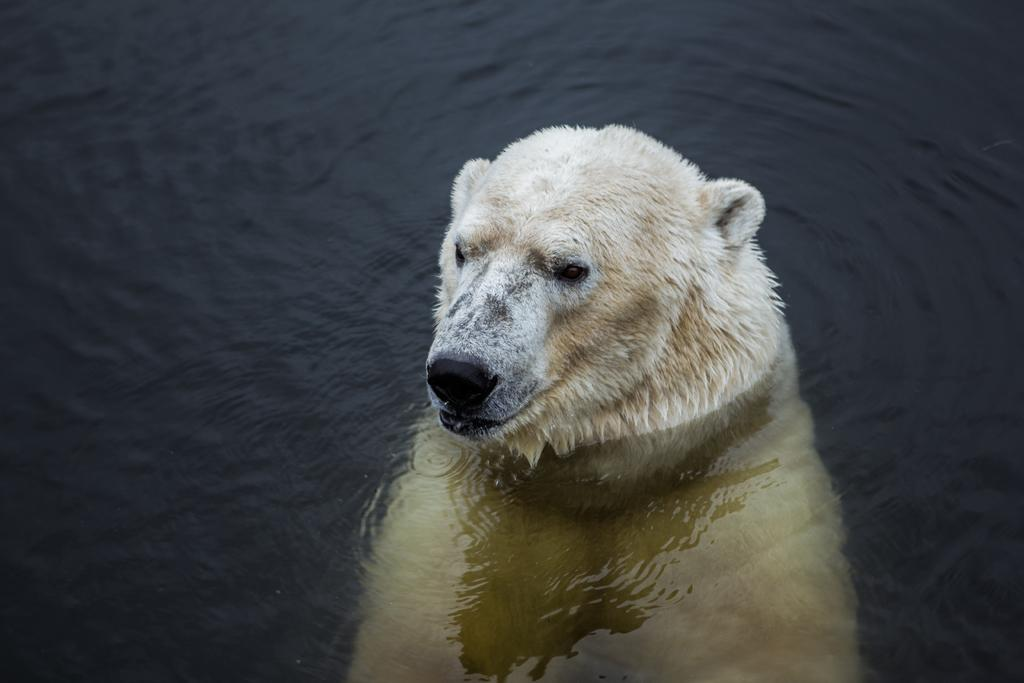What animal is in the image? There is a polar bear in the image. Where is the polar bear located in the image? The polar bear is in the water. What type of bean is being sold in the shop in the image? There is no shop or bean present in the image; it features a polar bear in the water. Can you see a kitten playing with the polar bear in the image? There is no kitten present in the image; it only features a polar bear in the water. 